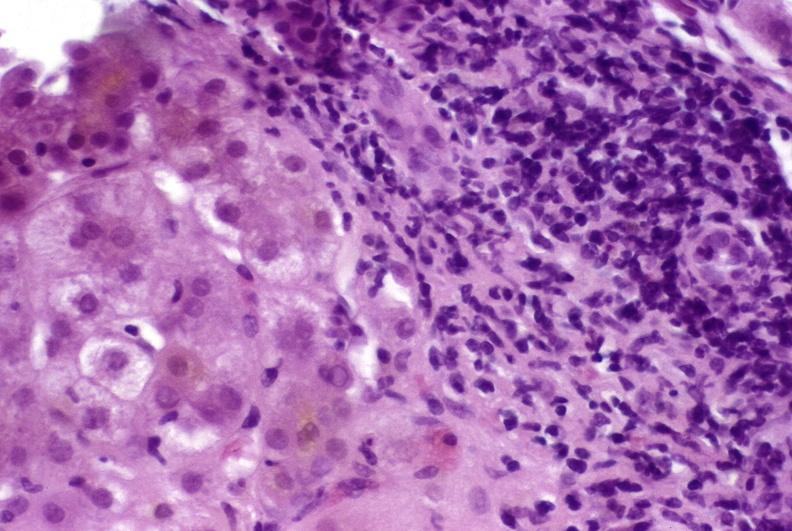s hepatobiliary present?
Answer the question using a single word or phrase. Yes 